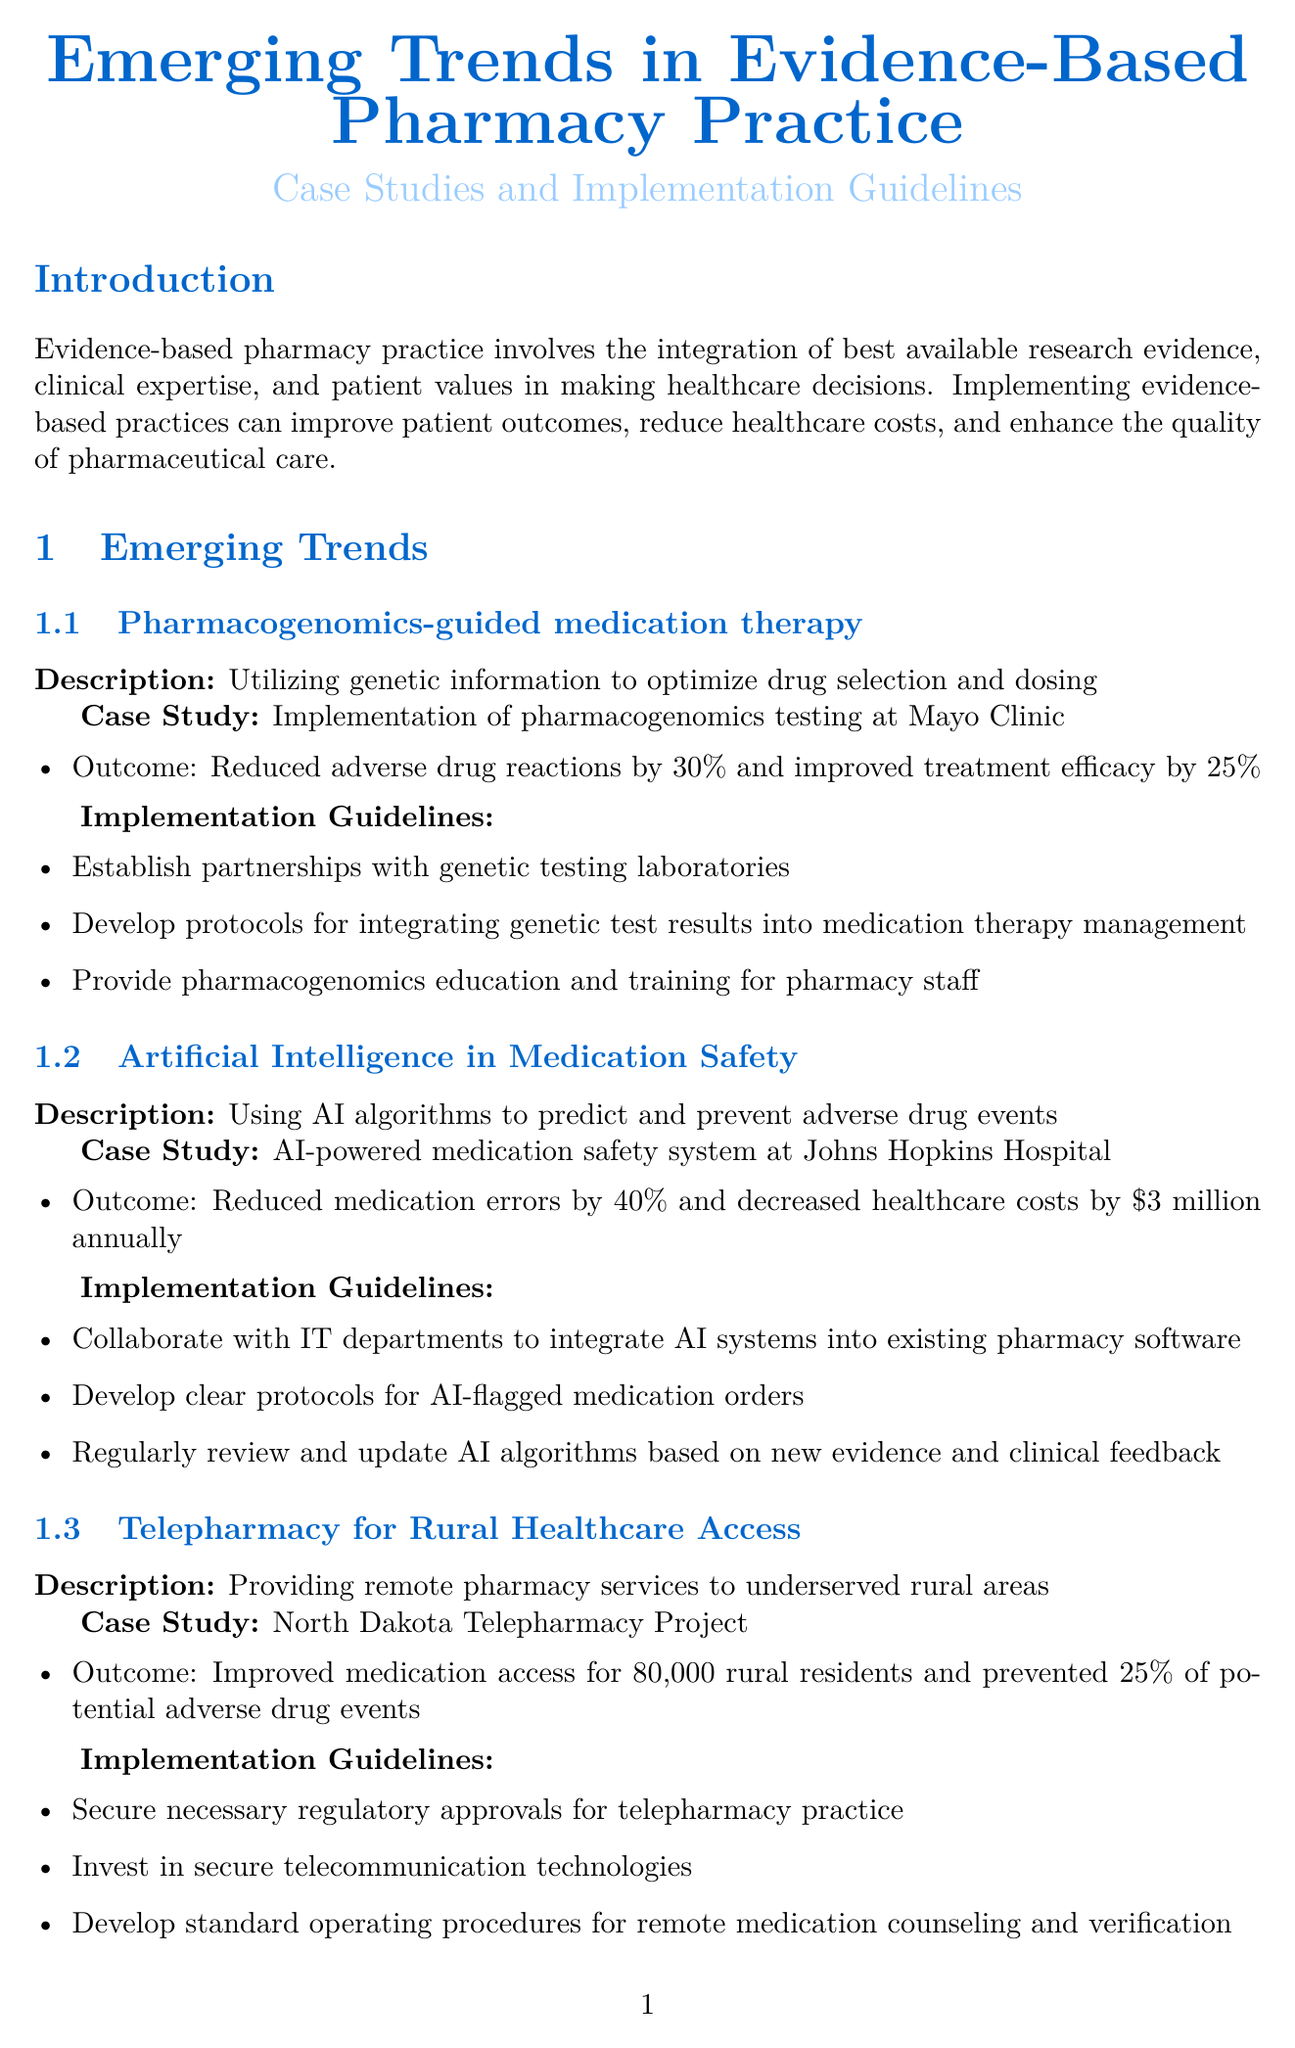What is the report title? The title is explicitly stated at the beginning of the report, summarizing the document's focus on pharmacy practice trends.
Answer: Emerging Trends in Evidence-Based Pharmacy Practice: Case Studies and Implementation Guidelines What is one outcome of the pharmacogenomics case study? The outcome details are provided in the case study section and highlight the benefits observed during implementation.
Answer: Reduced adverse drug reactions by 30% and improved treatment efficacy by 25% Which technology is used in medication safety according to the report? The report provides the name of the technology used in the emerging trend related to medication safety.
Answer: Artificial Intelligence How many rural residents benefited from the North Dakota Telepharmacy Project? The case study on telepharmacy lists the number of residents who gained access to medication services.
Answer: 80,000 What is one of the implementation challenges mentioned? The document lists several challenges related to implementing the emerging trends in pharmacy practice.
Answer: Limited financial resources for new technologies What does the term 'evidence-based pharmacy practice' refer to? The report includes a definition that clarifies this term's meaning in the context of healthcare decisions.
Answer: Integration of best available research evidence, clinical expertise, and patient values What is the goal of systematic literature reviews as mentioned in the document? The description section of evaluation methods specifies the purpose of systematic literature reviews.
Answer: Comprehensive analysis of published research on specific pharmacy interventions What is one of the reliable sources for randomized controlled trials listed? The list of reliable sources for various evaluation methods includes prominent medical journals as references.
Answer: New England Journal of Medicine 